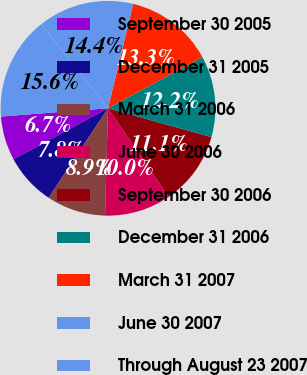<chart> <loc_0><loc_0><loc_500><loc_500><pie_chart><fcel>September 30 2005<fcel>December 31 2005<fcel>March 31 2006<fcel>June 30 2006<fcel>September 30 2006<fcel>December 31 2006<fcel>March 31 2007<fcel>June 30 2007<fcel>Through August 23 2007<nl><fcel>6.67%<fcel>7.78%<fcel>8.89%<fcel>10.0%<fcel>11.11%<fcel>12.22%<fcel>13.33%<fcel>14.44%<fcel>15.56%<nl></chart> 